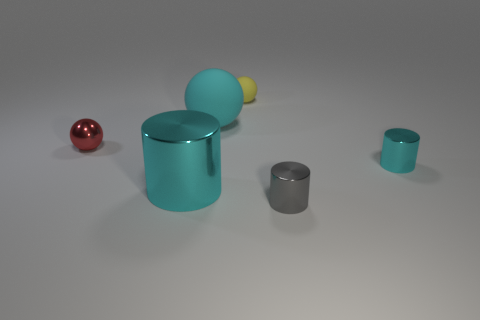Subtract all small cylinders. How many cylinders are left? 1 Subtract all cyan spheres. How many spheres are left? 2 Add 1 large spheres. How many objects exist? 7 Subtract all purple blocks. How many cyan cylinders are left? 2 Subtract 0 brown cylinders. How many objects are left? 6 Subtract 2 balls. How many balls are left? 1 Subtract all gray cylinders. Subtract all purple spheres. How many cylinders are left? 2 Subtract all cylinders. Subtract all small gray cylinders. How many objects are left? 2 Add 3 red spheres. How many red spheres are left? 4 Add 1 small red metal objects. How many small red metal objects exist? 2 